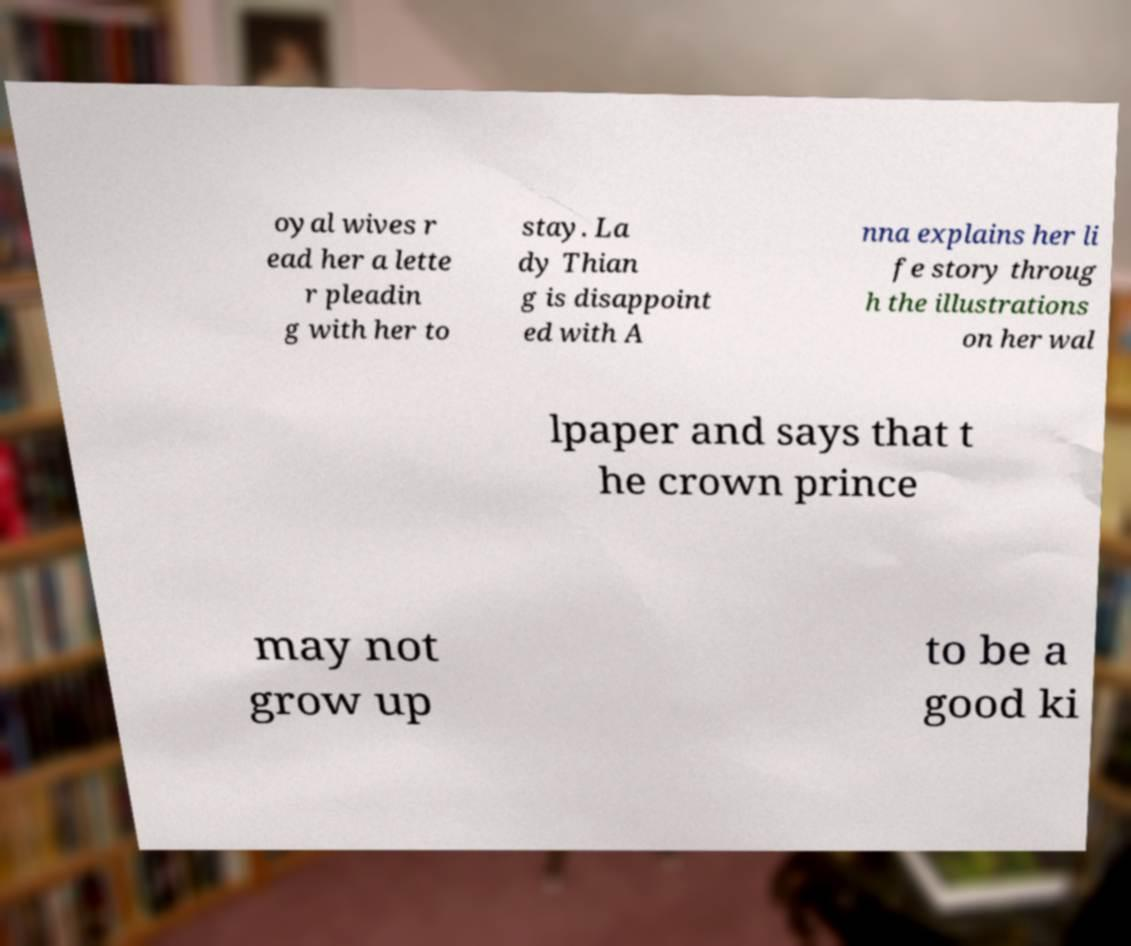Can you accurately transcribe the text from the provided image for me? oyal wives r ead her a lette r pleadin g with her to stay. La dy Thian g is disappoint ed with A nna explains her li fe story throug h the illustrations on her wal lpaper and says that t he crown prince may not grow up to be a good ki 